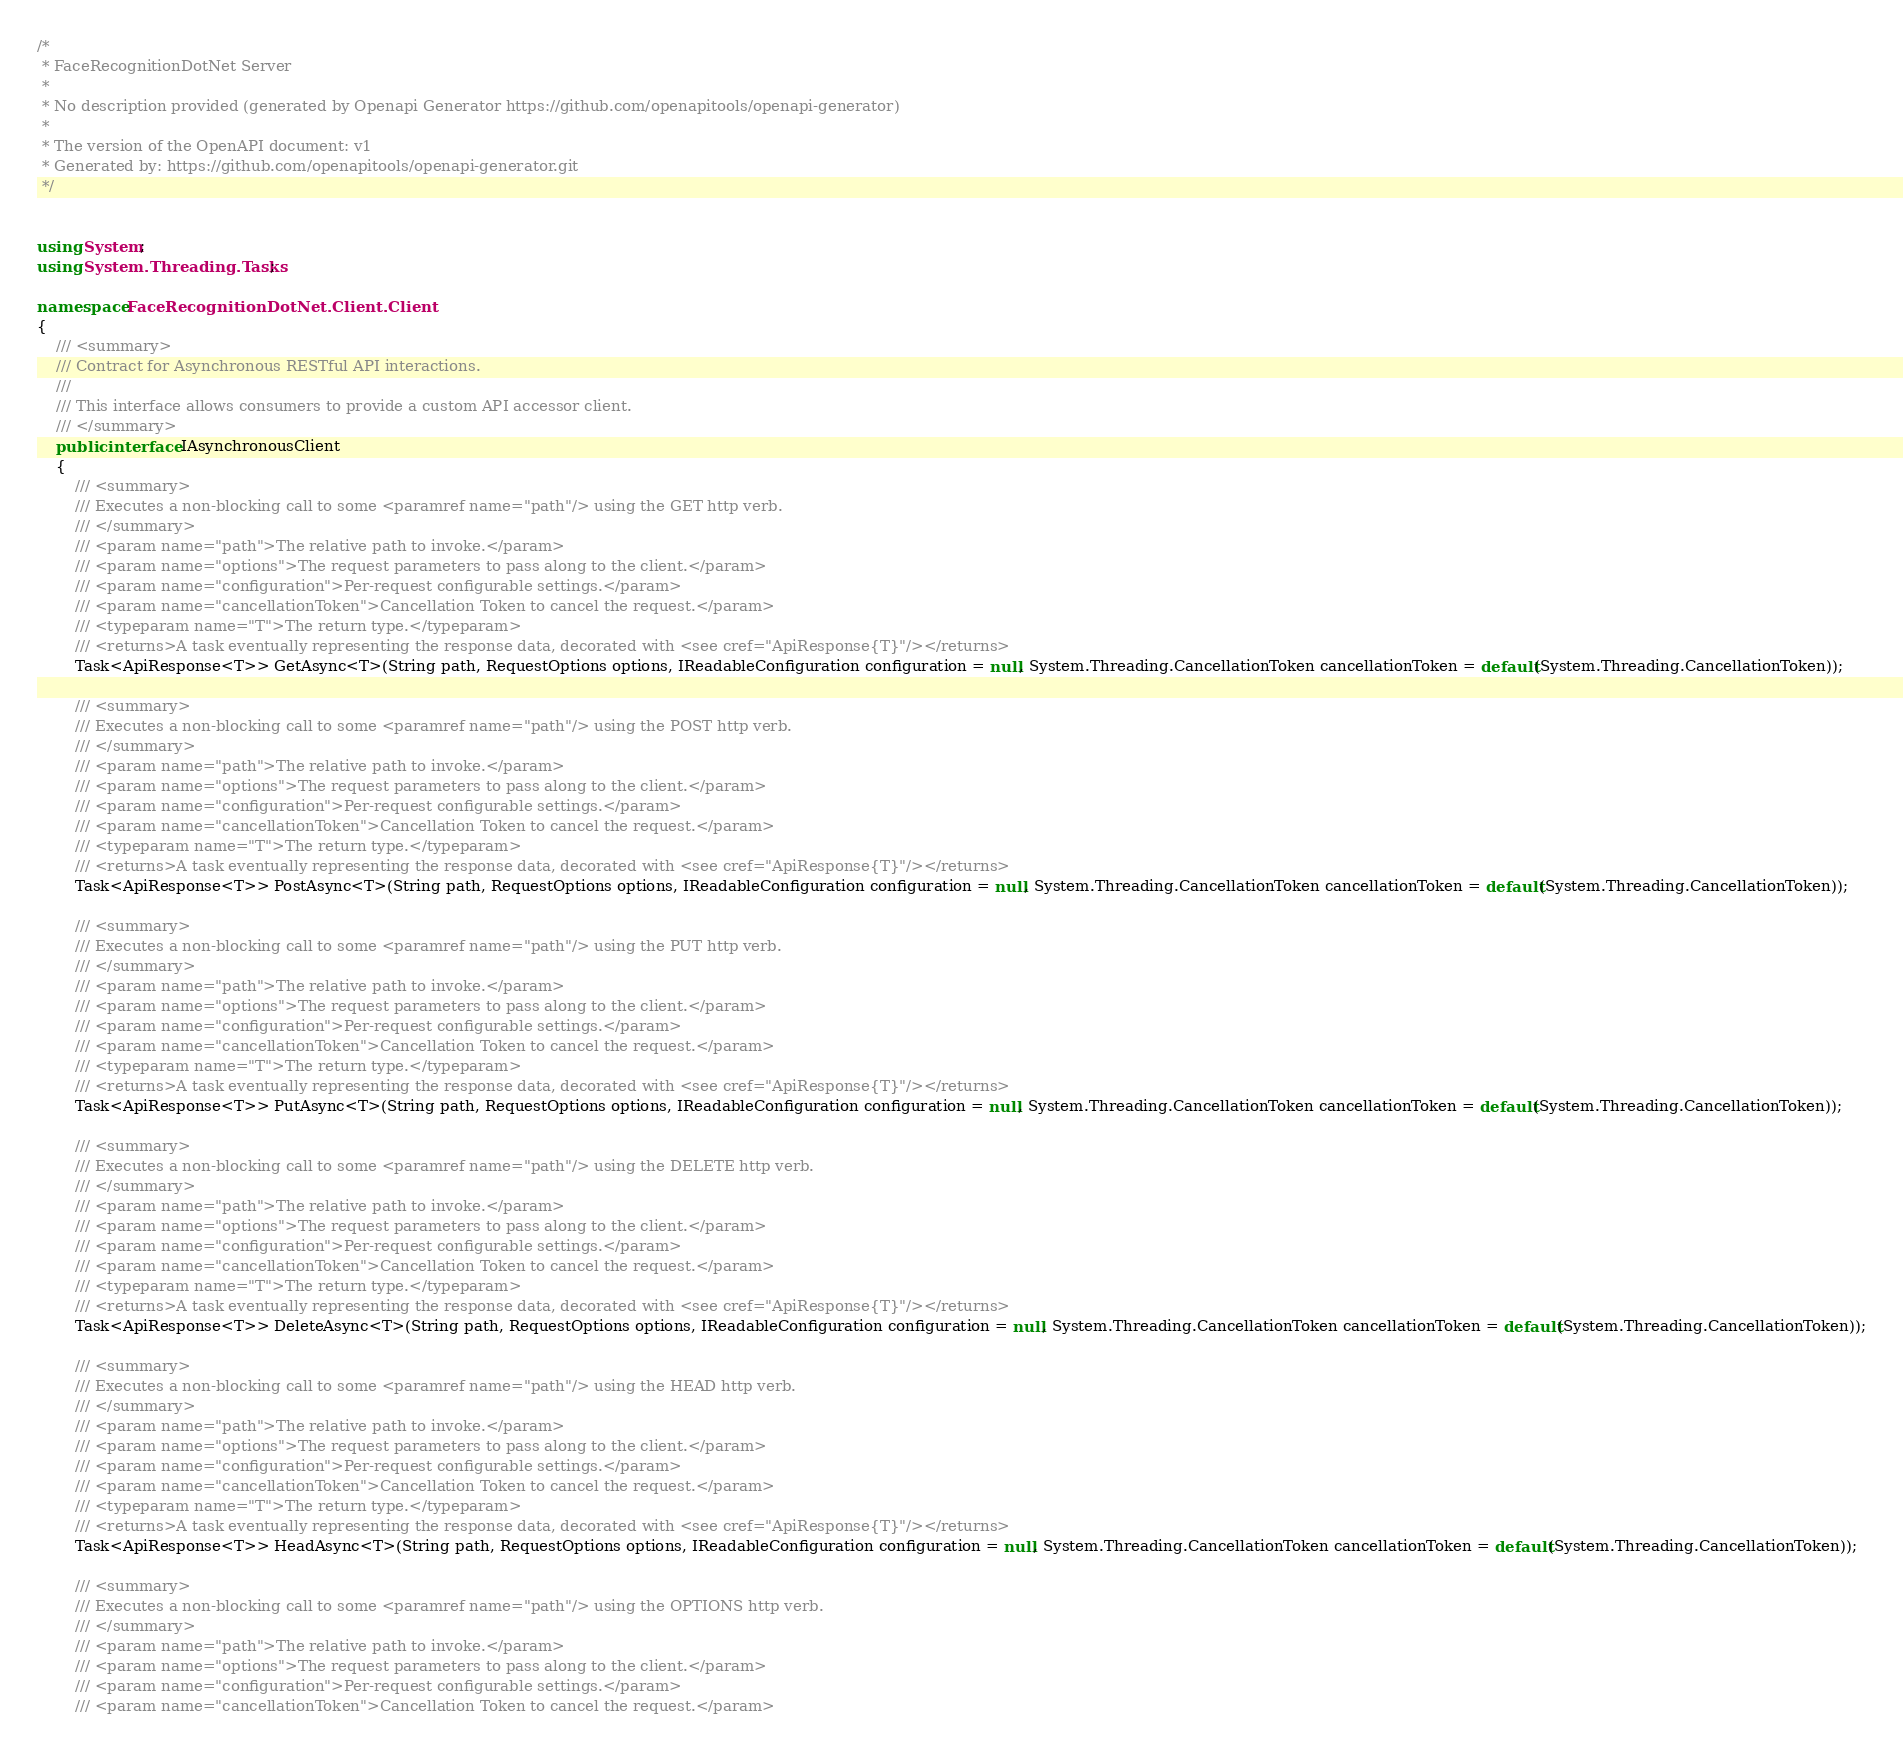Convert code to text. <code><loc_0><loc_0><loc_500><loc_500><_C#_>/*
 * FaceRecognitionDotNet Server
 *
 * No description provided (generated by Openapi Generator https://github.com/openapitools/openapi-generator)
 *
 * The version of the OpenAPI document: v1
 * Generated by: https://github.com/openapitools/openapi-generator.git
 */


using System;
using System.Threading.Tasks;

namespace FaceRecognitionDotNet.Client.Client
{
    /// <summary>
    /// Contract for Asynchronous RESTful API interactions.
    ///
    /// This interface allows consumers to provide a custom API accessor client.
    /// </summary>
    public interface IAsynchronousClient
    {
        /// <summary>
        /// Executes a non-blocking call to some <paramref name="path"/> using the GET http verb.
        /// </summary>
        /// <param name="path">The relative path to invoke.</param>
        /// <param name="options">The request parameters to pass along to the client.</param>
        /// <param name="configuration">Per-request configurable settings.</param>
        /// <param name="cancellationToken">Cancellation Token to cancel the request.</param>
        /// <typeparam name="T">The return type.</typeparam>
        /// <returns>A task eventually representing the response data, decorated with <see cref="ApiResponse{T}"/></returns>
        Task<ApiResponse<T>> GetAsync<T>(String path, RequestOptions options, IReadableConfiguration configuration = null, System.Threading.CancellationToken cancellationToken = default(System.Threading.CancellationToken));

        /// <summary>
        /// Executes a non-blocking call to some <paramref name="path"/> using the POST http verb.
        /// </summary>
        /// <param name="path">The relative path to invoke.</param>
        /// <param name="options">The request parameters to pass along to the client.</param>
        /// <param name="configuration">Per-request configurable settings.</param>
        /// <param name="cancellationToken">Cancellation Token to cancel the request.</param>
        /// <typeparam name="T">The return type.</typeparam>
        /// <returns>A task eventually representing the response data, decorated with <see cref="ApiResponse{T}"/></returns>
        Task<ApiResponse<T>> PostAsync<T>(String path, RequestOptions options, IReadableConfiguration configuration = null, System.Threading.CancellationToken cancellationToken = default(System.Threading.CancellationToken));

        /// <summary>
        /// Executes a non-blocking call to some <paramref name="path"/> using the PUT http verb.
        /// </summary>
        /// <param name="path">The relative path to invoke.</param>
        /// <param name="options">The request parameters to pass along to the client.</param>
        /// <param name="configuration">Per-request configurable settings.</param>
        /// <param name="cancellationToken">Cancellation Token to cancel the request.</param>
        /// <typeparam name="T">The return type.</typeparam>
        /// <returns>A task eventually representing the response data, decorated with <see cref="ApiResponse{T}"/></returns>
        Task<ApiResponse<T>> PutAsync<T>(String path, RequestOptions options, IReadableConfiguration configuration = null, System.Threading.CancellationToken cancellationToken = default(System.Threading.CancellationToken));

        /// <summary>
        /// Executes a non-blocking call to some <paramref name="path"/> using the DELETE http verb.
        /// </summary>
        /// <param name="path">The relative path to invoke.</param>
        /// <param name="options">The request parameters to pass along to the client.</param>
        /// <param name="configuration">Per-request configurable settings.</param>
        /// <param name="cancellationToken">Cancellation Token to cancel the request.</param>
        /// <typeparam name="T">The return type.</typeparam>
        /// <returns>A task eventually representing the response data, decorated with <see cref="ApiResponse{T}"/></returns>
        Task<ApiResponse<T>> DeleteAsync<T>(String path, RequestOptions options, IReadableConfiguration configuration = null, System.Threading.CancellationToken cancellationToken = default(System.Threading.CancellationToken));

        /// <summary>
        /// Executes a non-blocking call to some <paramref name="path"/> using the HEAD http verb.
        /// </summary>
        /// <param name="path">The relative path to invoke.</param>
        /// <param name="options">The request parameters to pass along to the client.</param>
        /// <param name="configuration">Per-request configurable settings.</param>
        /// <param name="cancellationToken">Cancellation Token to cancel the request.</param>
        /// <typeparam name="T">The return type.</typeparam>
        /// <returns>A task eventually representing the response data, decorated with <see cref="ApiResponse{T}"/></returns>
        Task<ApiResponse<T>> HeadAsync<T>(String path, RequestOptions options, IReadableConfiguration configuration = null, System.Threading.CancellationToken cancellationToken = default(System.Threading.CancellationToken));

        /// <summary>
        /// Executes a non-blocking call to some <paramref name="path"/> using the OPTIONS http verb.
        /// </summary>
        /// <param name="path">The relative path to invoke.</param>
        /// <param name="options">The request parameters to pass along to the client.</param>
        /// <param name="configuration">Per-request configurable settings.</param>
        /// <param name="cancellationToken">Cancellation Token to cancel the request.</param></code> 